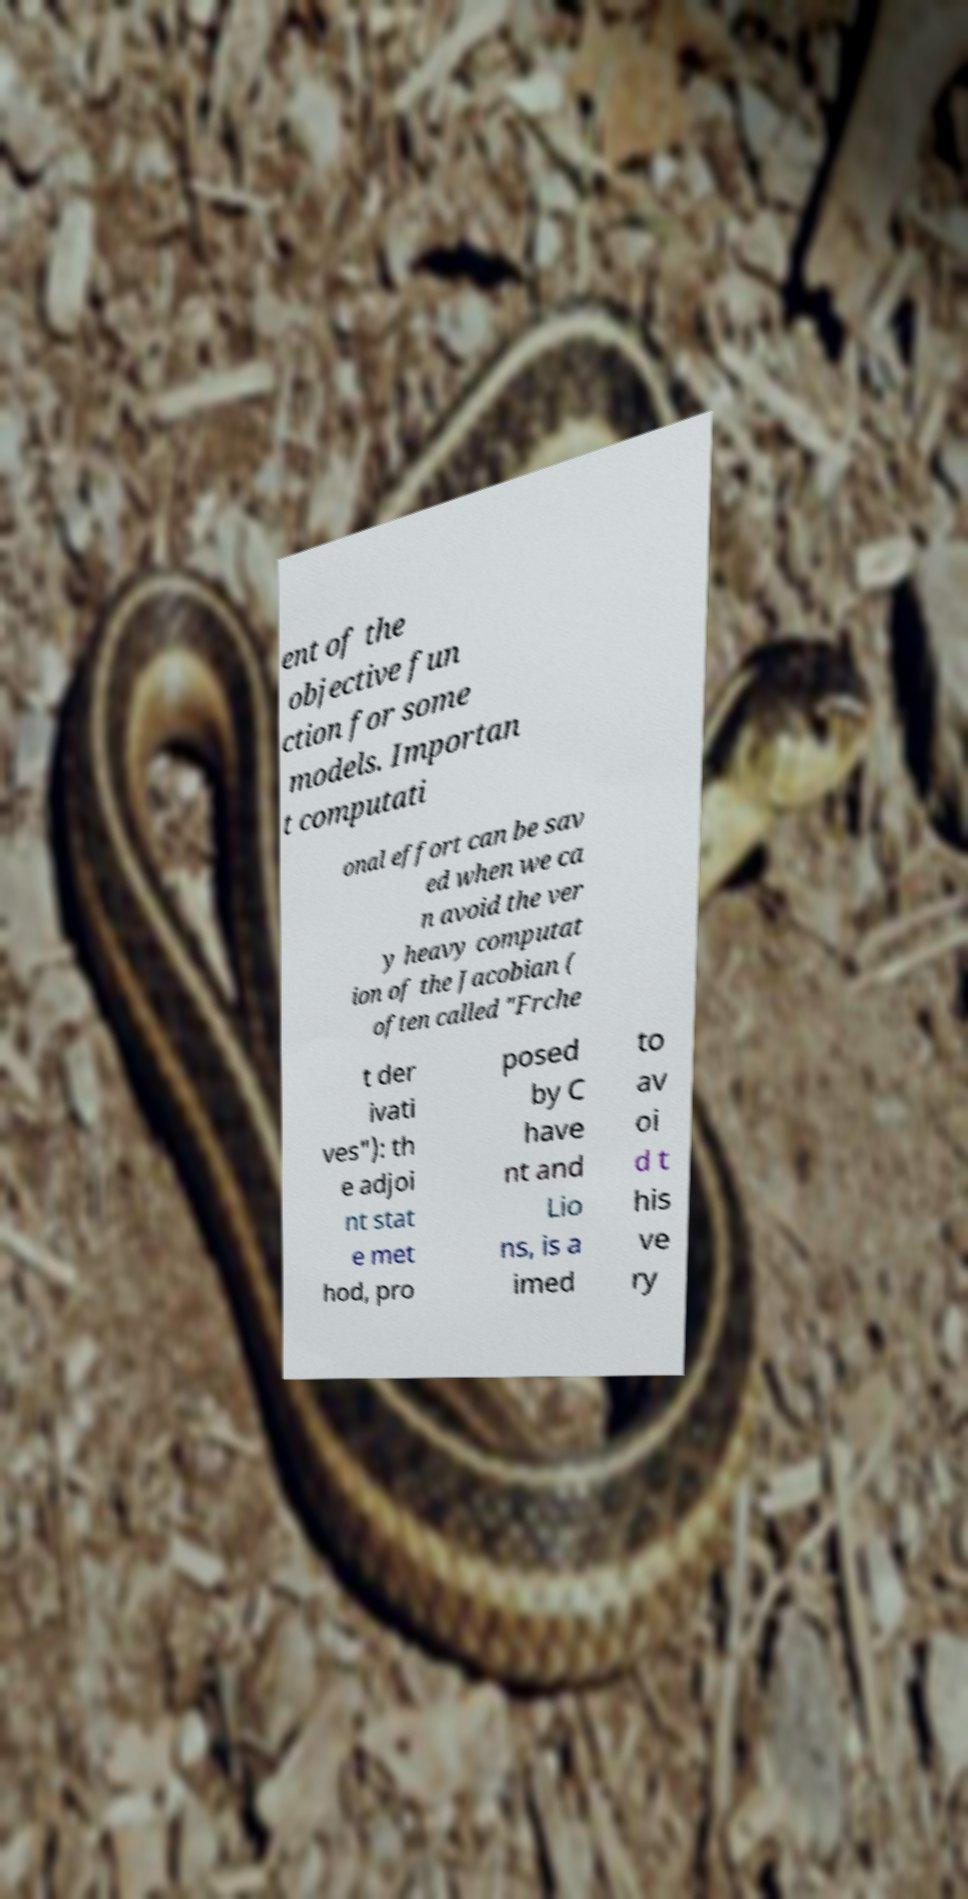Could you extract and type out the text from this image? ent of the objective fun ction for some models. Importan t computati onal effort can be sav ed when we ca n avoid the ver y heavy computat ion of the Jacobian ( often called "Frche t der ivati ves"): th e adjoi nt stat e met hod, pro posed by C have nt and Lio ns, is a imed to av oi d t his ve ry 